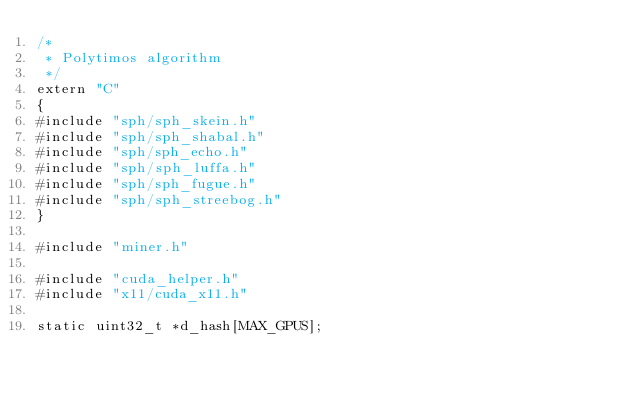<code> <loc_0><loc_0><loc_500><loc_500><_Cuda_>/*
 * Polytimos algorithm
 */
extern "C"
{
#include "sph/sph_skein.h"
#include "sph/sph_shabal.h"
#include "sph/sph_echo.h"
#include "sph/sph_luffa.h"
#include "sph/sph_fugue.h"
#include "sph/sph_streebog.h"
}

#include "miner.h"

#include "cuda_helper.h"
#include "x11/cuda_x11.h"

static uint32_t *d_hash[MAX_GPUS];</code> 